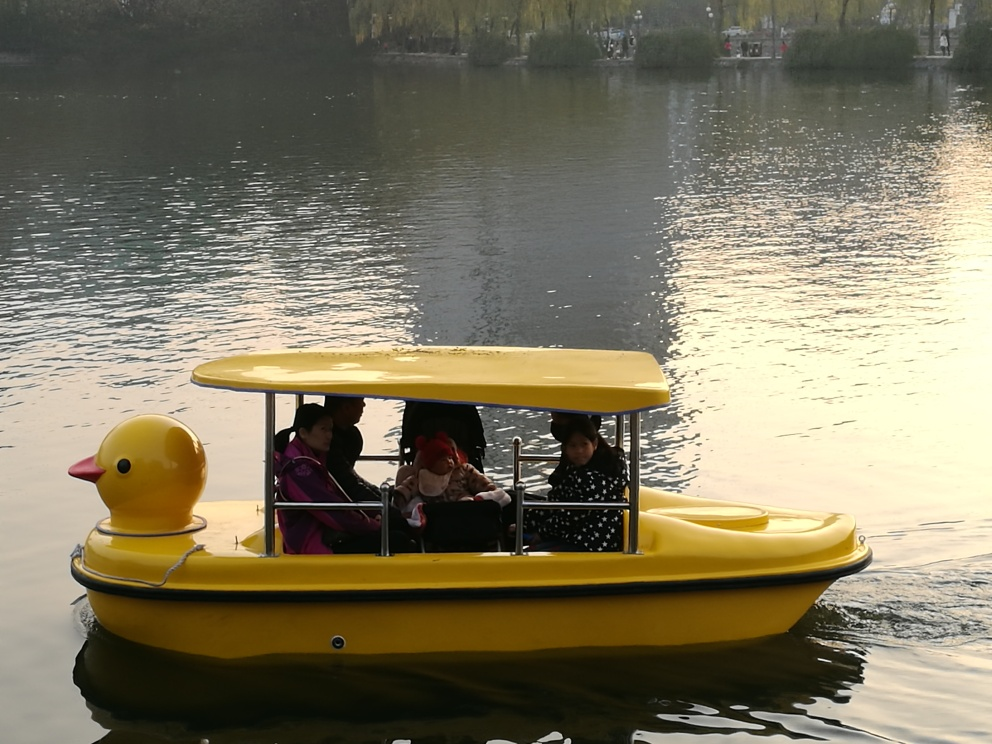Are there any exposure problems in the image? The image appears to be properly exposed, with no areas suffering from significant under or overexposure. Details are preserved in both the highlights and shadows, indicating a well-balanced exposure overall. 